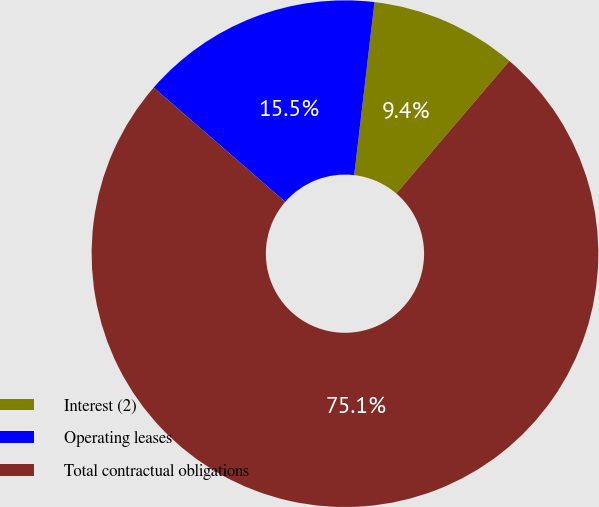Convert chart. <chart><loc_0><loc_0><loc_500><loc_500><pie_chart><fcel>Interest (2)<fcel>Operating leases<fcel>Total contractual obligations<nl><fcel>9.38%<fcel>15.48%<fcel>75.14%<nl></chart> 